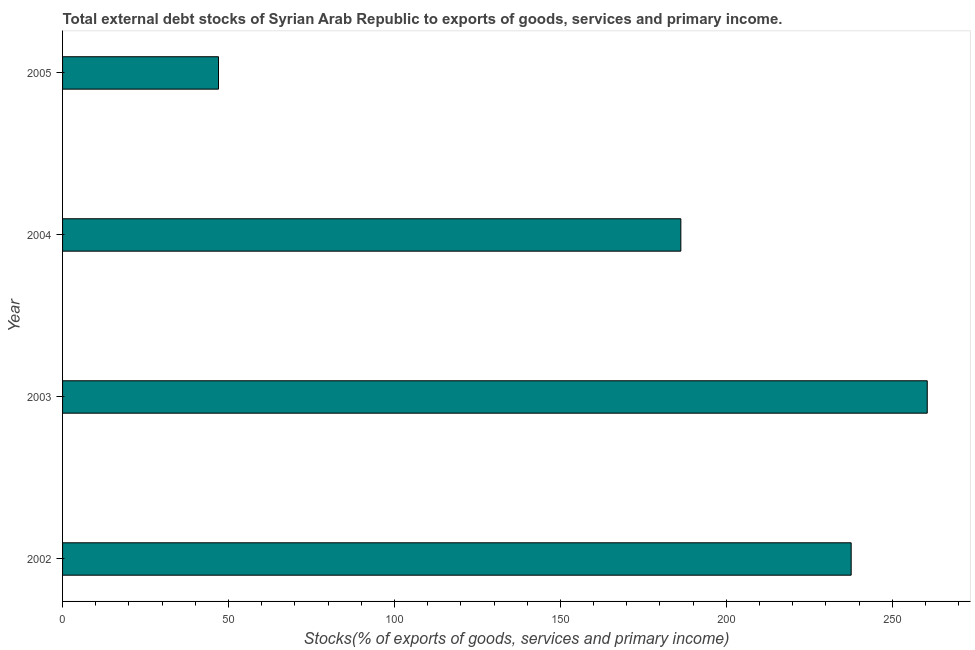Does the graph contain any zero values?
Give a very brief answer. No. What is the title of the graph?
Your answer should be very brief. Total external debt stocks of Syrian Arab Republic to exports of goods, services and primary income. What is the label or title of the X-axis?
Offer a very short reply. Stocks(% of exports of goods, services and primary income). What is the external debt stocks in 2003?
Make the answer very short. 260.53. Across all years, what is the maximum external debt stocks?
Your answer should be compact. 260.53. Across all years, what is the minimum external debt stocks?
Your response must be concise. 46.98. In which year was the external debt stocks maximum?
Ensure brevity in your answer.  2003. What is the sum of the external debt stocks?
Your answer should be compact. 731.41. What is the difference between the external debt stocks in 2004 and 2005?
Offer a terse response. 139.3. What is the average external debt stocks per year?
Your answer should be very brief. 182.85. What is the median external debt stocks?
Provide a short and direct response. 211.95. In how many years, is the external debt stocks greater than 80 %?
Keep it short and to the point. 3. What is the ratio of the external debt stocks in 2002 to that in 2004?
Make the answer very short. 1.27. What is the difference between the highest and the second highest external debt stocks?
Keep it short and to the point. 22.93. Is the sum of the external debt stocks in 2003 and 2004 greater than the maximum external debt stocks across all years?
Your response must be concise. Yes. What is the difference between the highest and the lowest external debt stocks?
Make the answer very short. 213.55. In how many years, is the external debt stocks greater than the average external debt stocks taken over all years?
Ensure brevity in your answer.  3. How many bars are there?
Provide a succinct answer. 4. Are all the bars in the graph horizontal?
Your response must be concise. Yes. How many years are there in the graph?
Your answer should be compact. 4. Are the values on the major ticks of X-axis written in scientific E-notation?
Your answer should be very brief. No. What is the Stocks(% of exports of goods, services and primary income) in 2002?
Provide a short and direct response. 237.61. What is the Stocks(% of exports of goods, services and primary income) of 2003?
Your response must be concise. 260.53. What is the Stocks(% of exports of goods, services and primary income) in 2004?
Keep it short and to the point. 186.29. What is the Stocks(% of exports of goods, services and primary income) of 2005?
Your answer should be very brief. 46.98. What is the difference between the Stocks(% of exports of goods, services and primary income) in 2002 and 2003?
Your answer should be very brief. -22.92. What is the difference between the Stocks(% of exports of goods, services and primary income) in 2002 and 2004?
Provide a succinct answer. 51.32. What is the difference between the Stocks(% of exports of goods, services and primary income) in 2002 and 2005?
Give a very brief answer. 190.62. What is the difference between the Stocks(% of exports of goods, services and primary income) in 2003 and 2004?
Your response must be concise. 74.24. What is the difference between the Stocks(% of exports of goods, services and primary income) in 2003 and 2005?
Your answer should be very brief. 213.55. What is the difference between the Stocks(% of exports of goods, services and primary income) in 2004 and 2005?
Give a very brief answer. 139.3. What is the ratio of the Stocks(% of exports of goods, services and primary income) in 2002 to that in 2003?
Your answer should be compact. 0.91. What is the ratio of the Stocks(% of exports of goods, services and primary income) in 2002 to that in 2004?
Provide a short and direct response. 1.27. What is the ratio of the Stocks(% of exports of goods, services and primary income) in 2002 to that in 2005?
Your response must be concise. 5.06. What is the ratio of the Stocks(% of exports of goods, services and primary income) in 2003 to that in 2004?
Your answer should be very brief. 1.4. What is the ratio of the Stocks(% of exports of goods, services and primary income) in 2003 to that in 2005?
Offer a very short reply. 5.54. What is the ratio of the Stocks(% of exports of goods, services and primary income) in 2004 to that in 2005?
Keep it short and to the point. 3.96. 